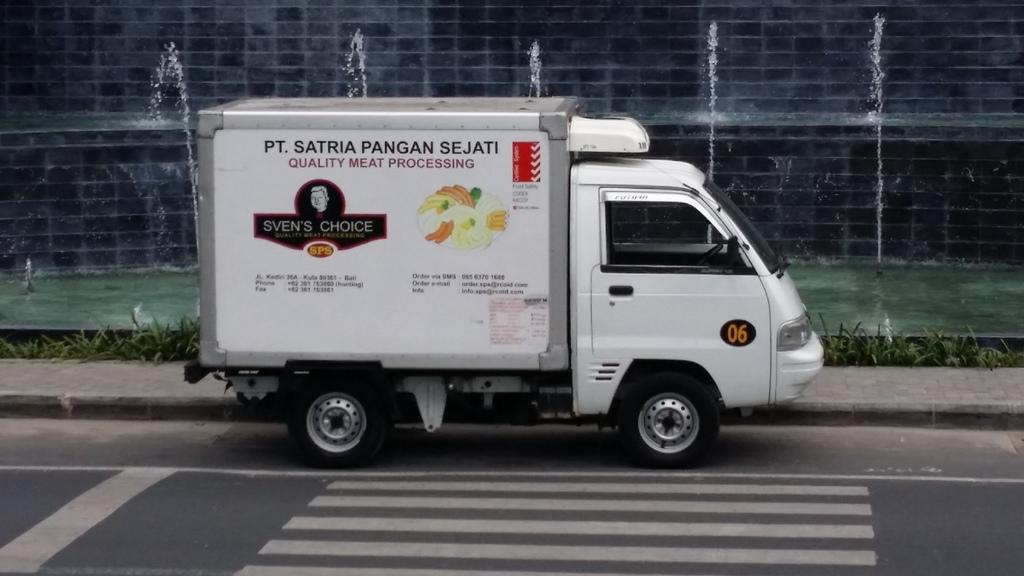What is on the road in the image? There is a vehicle on the road in the image. What is located next to the road? There is a sidewalk next to the road. What type of vegetation can be seen in the image? There are plants visible in the image. What can be seen in the background of the image? There is a wall and a water fountain in the background of the image. What type of payment is required to use the plate in the image? There is no plate present in the image, so no payment is required. 